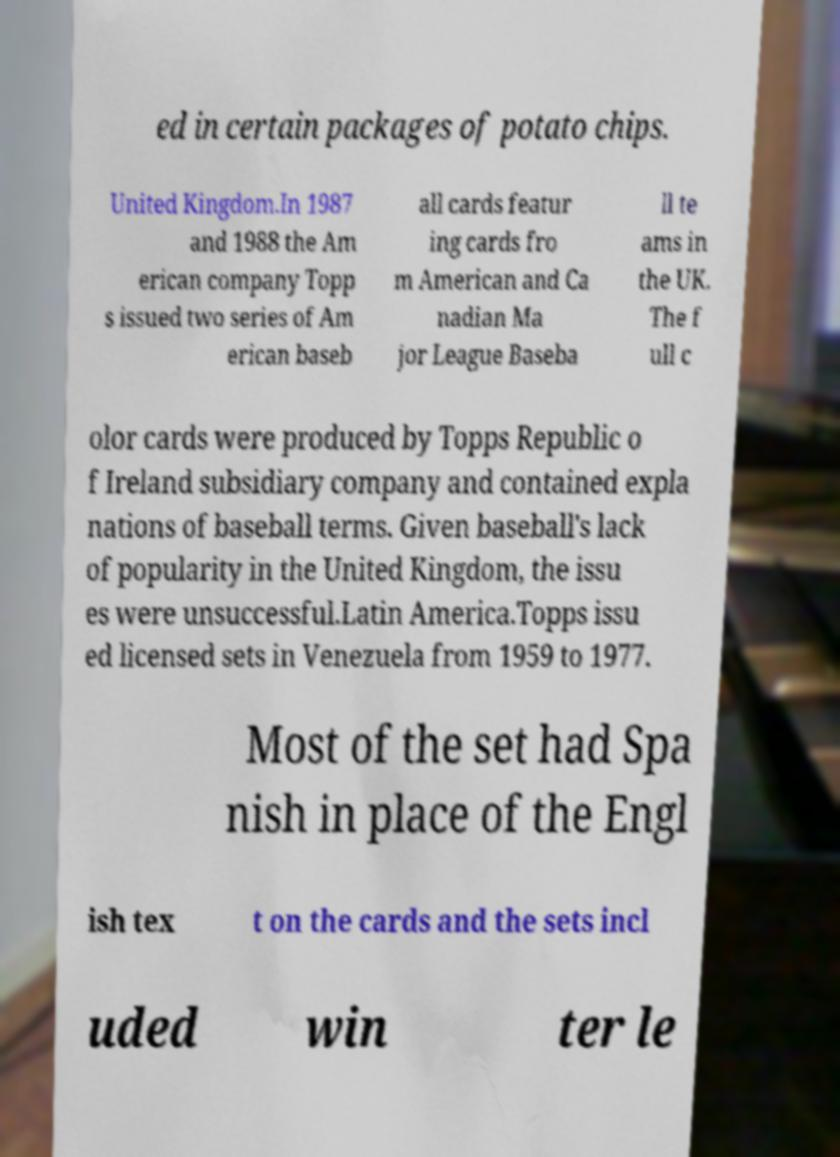Can you read and provide the text displayed in the image?This photo seems to have some interesting text. Can you extract and type it out for me? ed in certain packages of potato chips. United Kingdom.In 1987 and 1988 the Am erican company Topp s issued two series of Am erican baseb all cards featur ing cards fro m American and Ca nadian Ma jor League Baseba ll te ams in the UK. The f ull c olor cards were produced by Topps Republic o f Ireland subsidiary company and contained expla nations of baseball terms. Given baseball's lack of popularity in the United Kingdom, the issu es were unsuccessful.Latin America.Topps issu ed licensed sets in Venezuela from 1959 to 1977. Most of the set had Spa nish in place of the Engl ish tex t on the cards and the sets incl uded win ter le 